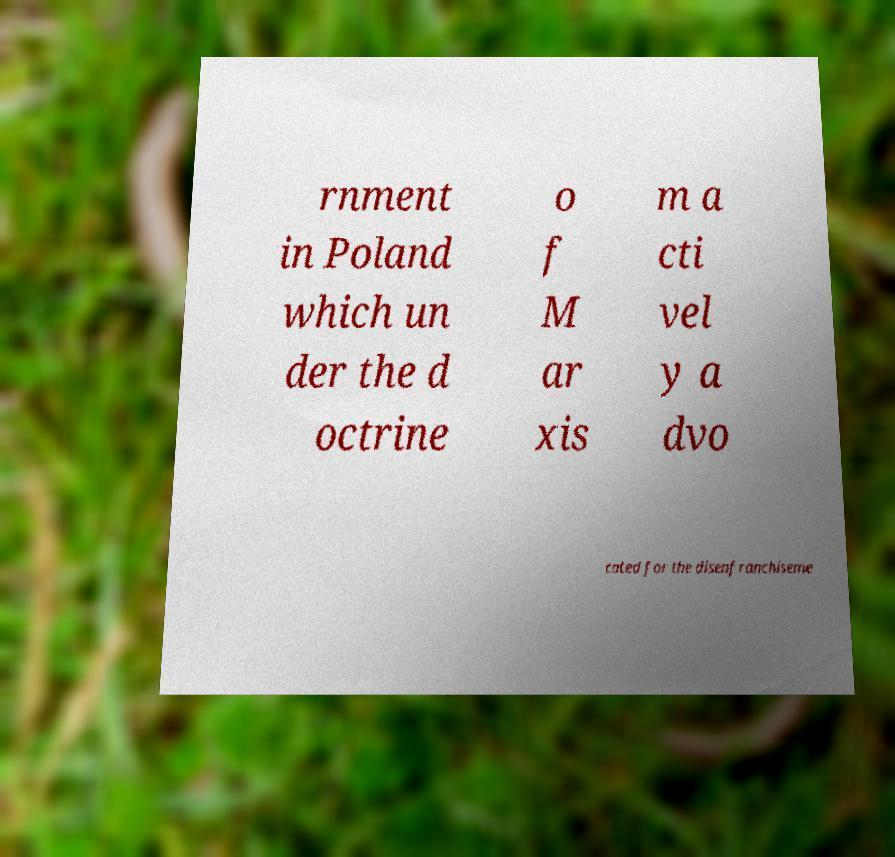Can you read and provide the text displayed in the image?This photo seems to have some interesting text. Can you extract and type it out for me? rnment in Poland which un der the d octrine o f M ar xis m a cti vel y a dvo cated for the disenfranchiseme 